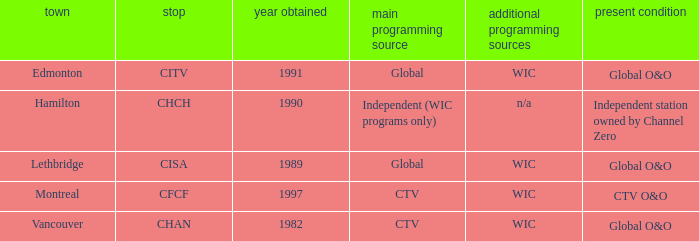How many channels were gained in 1997 1.0. I'm looking to parse the entire table for insights. Could you assist me with that? {'header': ['town', 'stop', 'year obtained', 'main programming source', 'additional programming sources', 'present condition'], 'rows': [['Edmonton', 'CITV', '1991', 'Global', 'WIC', 'Global O&O'], ['Hamilton', 'CHCH', '1990', 'Independent (WIC programs only)', 'n/a', 'Independent station owned by Channel Zero'], ['Lethbridge', 'CISA', '1989', 'Global', 'WIC', 'Global O&O'], ['Montreal', 'CFCF', '1997', 'CTV', 'WIC', 'CTV O&O'], ['Vancouver', 'CHAN', '1982', 'CTV', 'WIC', 'Global O&O']]} 